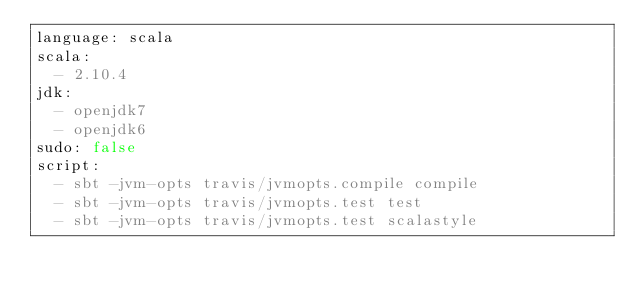Convert code to text. <code><loc_0><loc_0><loc_500><loc_500><_YAML_>language: scala
scala:
  - 2.10.4
jdk:
  - openjdk7
  - openjdk6
sudo: false
script:
  - sbt -jvm-opts travis/jvmopts.compile compile
  - sbt -jvm-opts travis/jvmopts.test test
  - sbt -jvm-opts travis/jvmopts.test scalastyle
</code> 